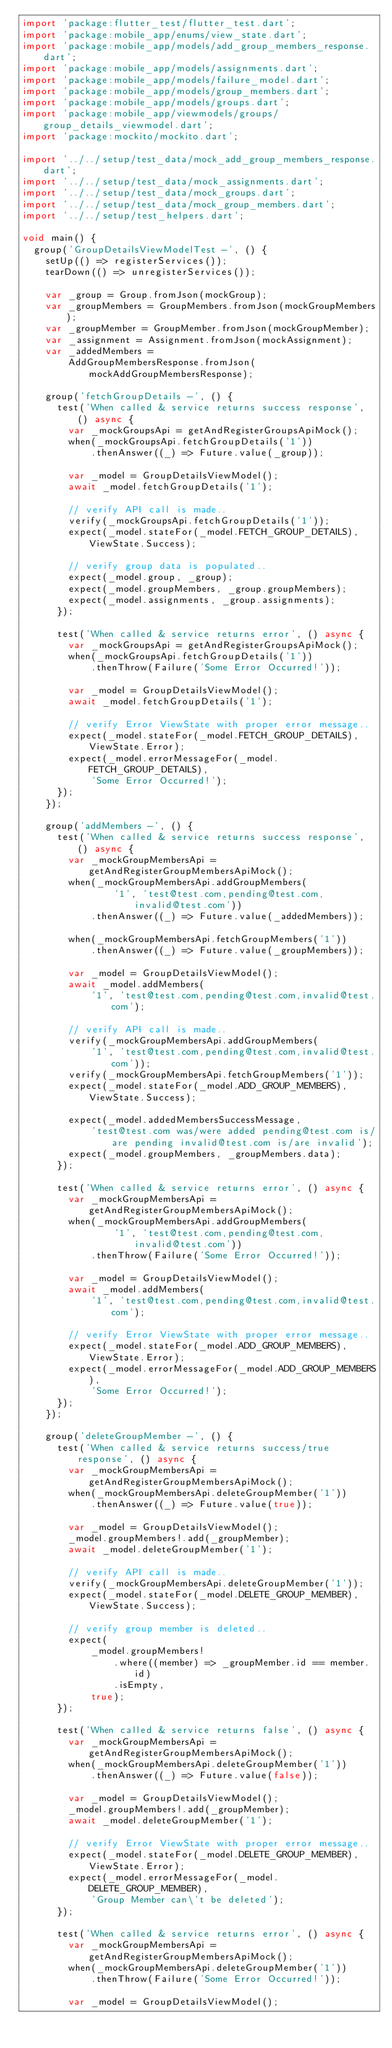Convert code to text. <code><loc_0><loc_0><loc_500><loc_500><_Dart_>import 'package:flutter_test/flutter_test.dart';
import 'package:mobile_app/enums/view_state.dart';
import 'package:mobile_app/models/add_group_members_response.dart';
import 'package:mobile_app/models/assignments.dart';
import 'package:mobile_app/models/failure_model.dart';
import 'package:mobile_app/models/group_members.dart';
import 'package:mobile_app/models/groups.dart';
import 'package:mobile_app/viewmodels/groups/group_details_viewmodel.dart';
import 'package:mockito/mockito.dart';

import '../../setup/test_data/mock_add_group_members_response.dart';
import '../../setup/test_data/mock_assignments.dart';
import '../../setup/test_data/mock_groups.dart';
import '../../setup/test_data/mock_group_members.dart';
import '../../setup/test_helpers.dart';

void main() {
  group('GroupDetailsViewModelTest -', () {
    setUp(() => registerServices());
    tearDown(() => unregisterServices());

    var _group = Group.fromJson(mockGroup);
    var _groupMembers = GroupMembers.fromJson(mockGroupMembers);
    var _groupMember = GroupMember.fromJson(mockGroupMember);
    var _assignment = Assignment.fromJson(mockAssignment);
    var _addedMembers =
        AddGroupMembersResponse.fromJson(mockAddGroupMembersResponse);

    group('fetchGroupDetails -', () {
      test('When called & service returns success response', () async {
        var _mockGroupsApi = getAndRegisterGroupsApiMock();
        when(_mockGroupsApi.fetchGroupDetails('1'))
            .thenAnswer((_) => Future.value(_group));

        var _model = GroupDetailsViewModel();
        await _model.fetchGroupDetails('1');

        // verify API call is made..
        verify(_mockGroupsApi.fetchGroupDetails('1'));
        expect(_model.stateFor(_model.FETCH_GROUP_DETAILS), ViewState.Success);

        // verify group data is populated..
        expect(_model.group, _group);
        expect(_model.groupMembers, _group.groupMembers);
        expect(_model.assignments, _group.assignments);
      });

      test('When called & service returns error', () async {
        var _mockGroupsApi = getAndRegisterGroupsApiMock();
        when(_mockGroupsApi.fetchGroupDetails('1'))
            .thenThrow(Failure('Some Error Occurred!'));

        var _model = GroupDetailsViewModel();
        await _model.fetchGroupDetails('1');

        // verify Error ViewState with proper error message..
        expect(_model.stateFor(_model.FETCH_GROUP_DETAILS), ViewState.Error);
        expect(_model.errorMessageFor(_model.FETCH_GROUP_DETAILS),
            'Some Error Occurred!');
      });
    });

    group('addMembers -', () {
      test('When called & service returns success response', () async {
        var _mockGroupMembersApi = getAndRegisterGroupMembersApiMock();
        when(_mockGroupMembersApi.addGroupMembers(
                '1', 'test@test.com,pending@test.com,invalid@test.com'))
            .thenAnswer((_) => Future.value(_addedMembers));

        when(_mockGroupMembersApi.fetchGroupMembers('1'))
            .thenAnswer((_) => Future.value(_groupMembers));

        var _model = GroupDetailsViewModel();
        await _model.addMembers(
            '1', 'test@test.com,pending@test.com,invalid@test.com');

        // verify API call is made..
        verify(_mockGroupMembersApi.addGroupMembers(
            '1', 'test@test.com,pending@test.com,invalid@test.com'));
        verify(_mockGroupMembersApi.fetchGroupMembers('1'));
        expect(_model.stateFor(_model.ADD_GROUP_MEMBERS), ViewState.Success);

        expect(_model.addedMembersSuccessMessage,
            'test@test.com was/were added pending@test.com is/are pending invalid@test.com is/are invalid');
        expect(_model.groupMembers, _groupMembers.data);
      });

      test('When called & service returns error', () async {
        var _mockGroupMembersApi = getAndRegisterGroupMembersApiMock();
        when(_mockGroupMembersApi.addGroupMembers(
                '1', 'test@test.com,pending@test.com,invalid@test.com'))
            .thenThrow(Failure('Some Error Occurred!'));

        var _model = GroupDetailsViewModel();
        await _model.addMembers(
            '1', 'test@test.com,pending@test.com,invalid@test.com');

        // verify Error ViewState with proper error message..
        expect(_model.stateFor(_model.ADD_GROUP_MEMBERS), ViewState.Error);
        expect(_model.errorMessageFor(_model.ADD_GROUP_MEMBERS),
            'Some Error Occurred!');
      });
    });

    group('deleteGroupMember -', () {
      test('When called & service returns success/true response', () async {
        var _mockGroupMembersApi = getAndRegisterGroupMembersApiMock();
        when(_mockGroupMembersApi.deleteGroupMember('1'))
            .thenAnswer((_) => Future.value(true));

        var _model = GroupDetailsViewModel();
        _model.groupMembers!.add(_groupMember);
        await _model.deleteGroupMember('1');

        // verify API call is made..
        verify(_mockGroupMembersApi.deleteGroupMember('1'));
        expect(_model.stateFor(_model.DELETE_GROUP_MEMBER), ViewState.Success);

        // verify group member is deleted..
        expect(
            _model.groupMembers!
                .where((member) => _groupMember.id == member.id)
                .isEmpty,
            true);
      });

      test('When called & service returns false', () async {
        var _mockGroupMembersApi = getAndRegisterGroupMembersApiMock();
        when(_mockGroupMembersApi.deleteGroupMember('1'))
            .thenAnswer((_) => Future.value(false));

        var _model = GroupDetailsViewModel();
        _model.groupMembers!.add(_groupMember);
        await _model.deleteGroupMember('1');

        // verify Error ViewState with proper error message..
        expect(_model.stateFor(_model.DELETE_GROUP_MEMBER), ViewState.Error);
        expect(_model.errorMessageFor(_model.DELETE_GROUP_MEMBER),
            'Group Member can\'t be deleted');
      });

      test('When called & service returns error', () async {
        var _mockGroupMembersApi = getAndRegisterGroupMembersApiMock();
        when(_mockGroupMembersApi.deleteGroupMember('1'))
            .thenThrow(Failure('Some Error Occurred!'));

        var _model = GroupDetailsViewModel();</code> 